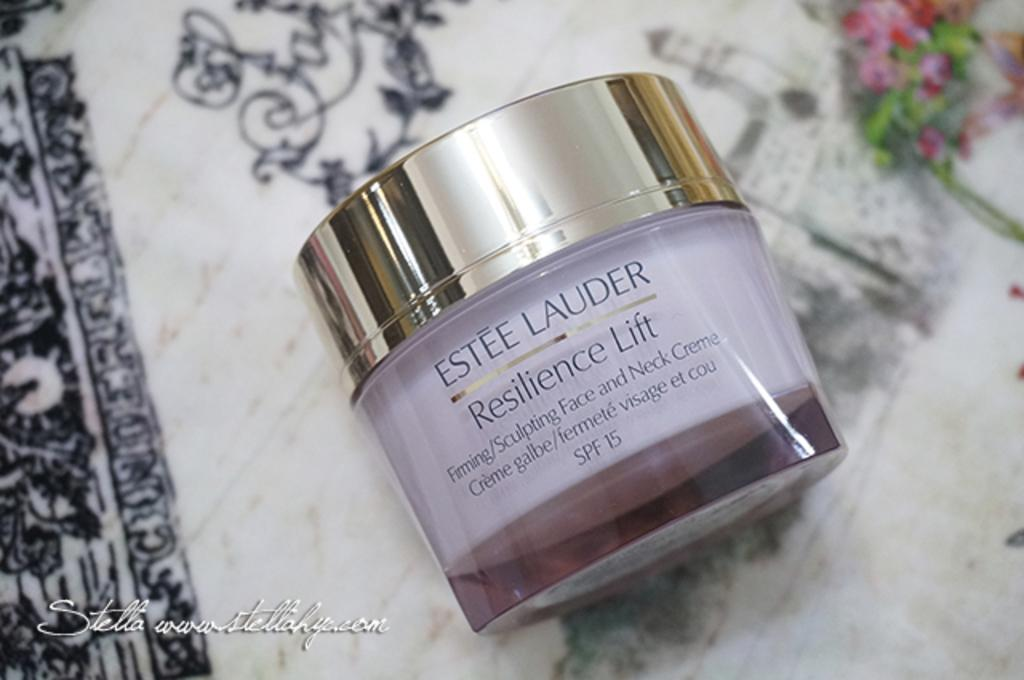<image>
Provide a brief description of the given image. A sculpting face and neck cream called Estee Lauder 